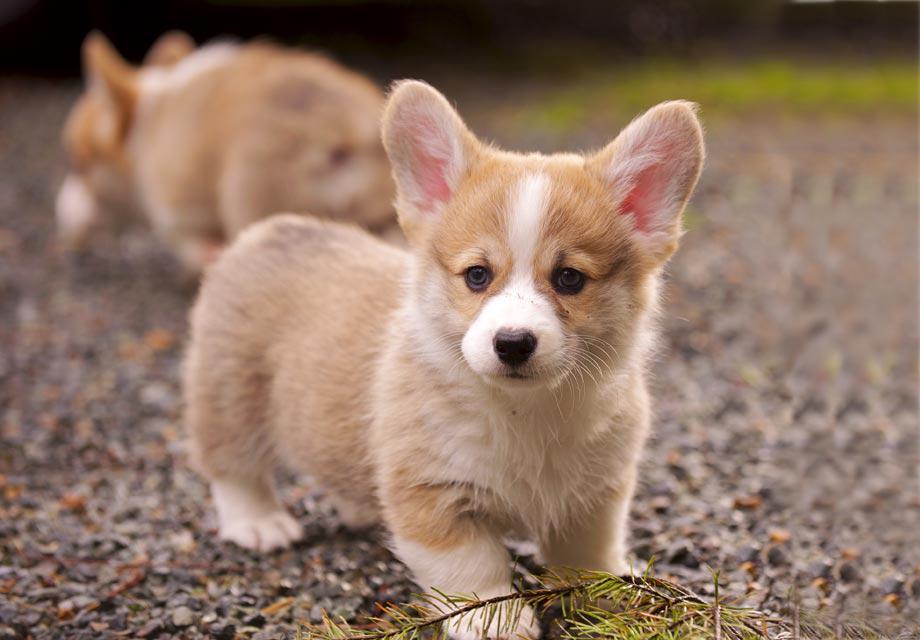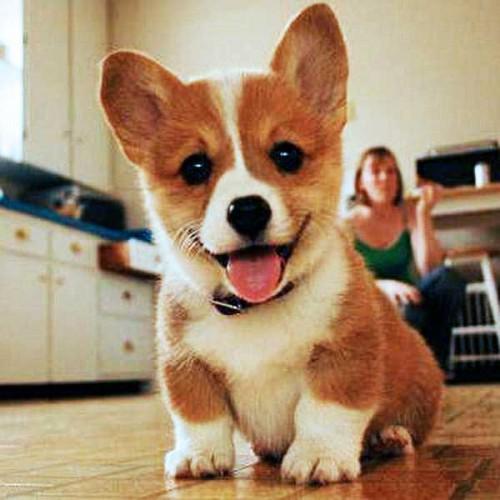The first image is the image on the left, the second image is the image on the right. Given the left and right images, does the statement "The righthand image contains a single dog, which is tri-colored and sitting upright, with its mouth closed." hold true? Answer yes or no. No. The first image is the image on the left, the second image is the image on the right. For the images displayed, is the sentence "There is exactly three puppies." factually correct? Answer yes or no. Yes. 